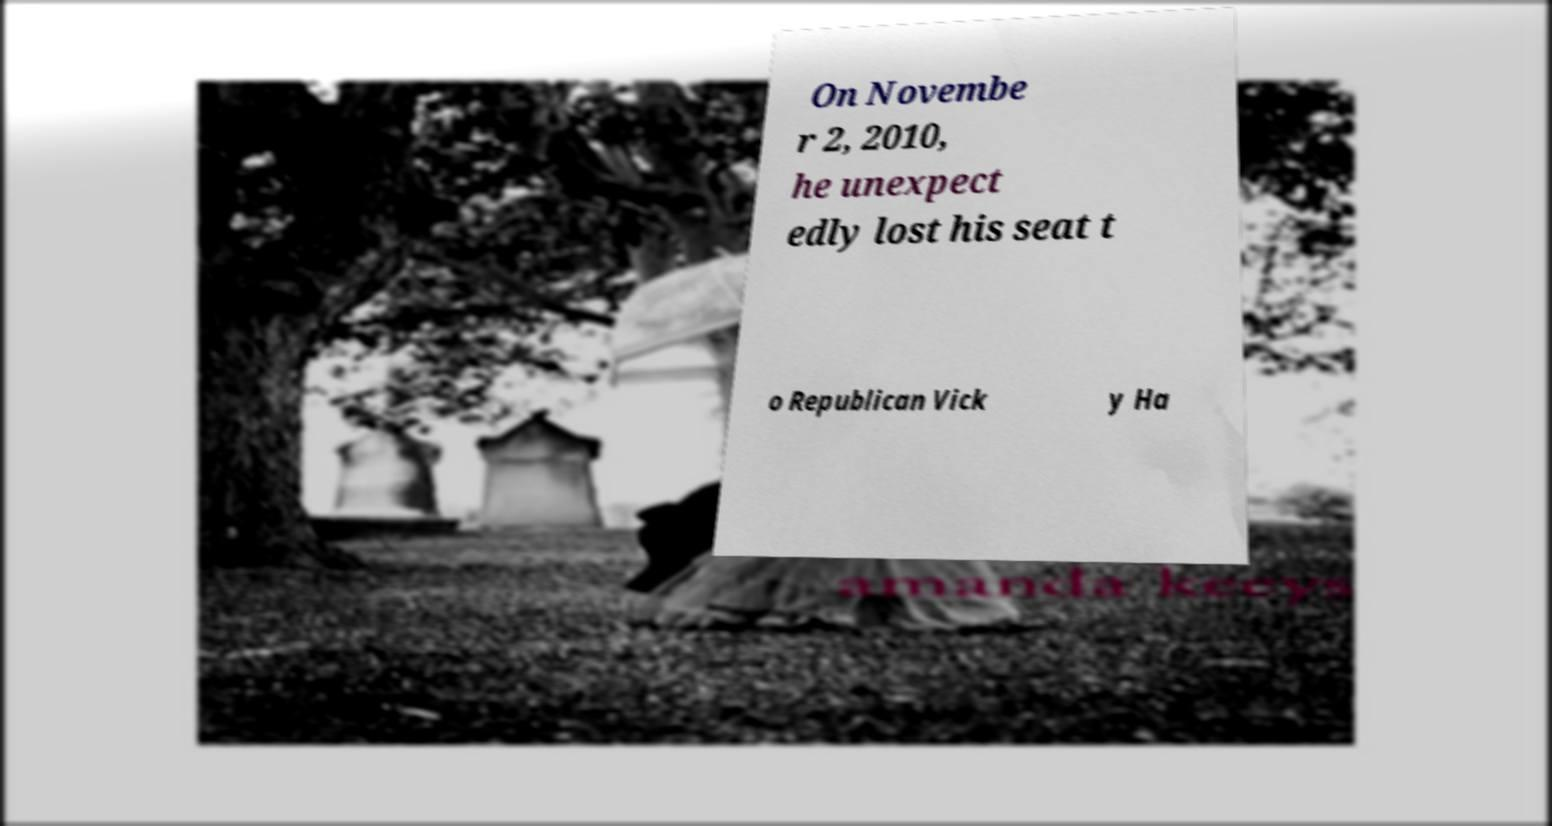Could you assist in decoding the text presented in this image and type it out clearly? On Novembe r 2, 2010, he unexpect edly lost his seat t o Republican Vick y Ha 